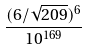<formula> <loc_0><loc_0><loc_500><loc_500>\frac { ( 6 / \sqrt { 2 0 9 } ) ^ { 6 } } { 1 0 ^ { 1 6 9 } }</formula> 